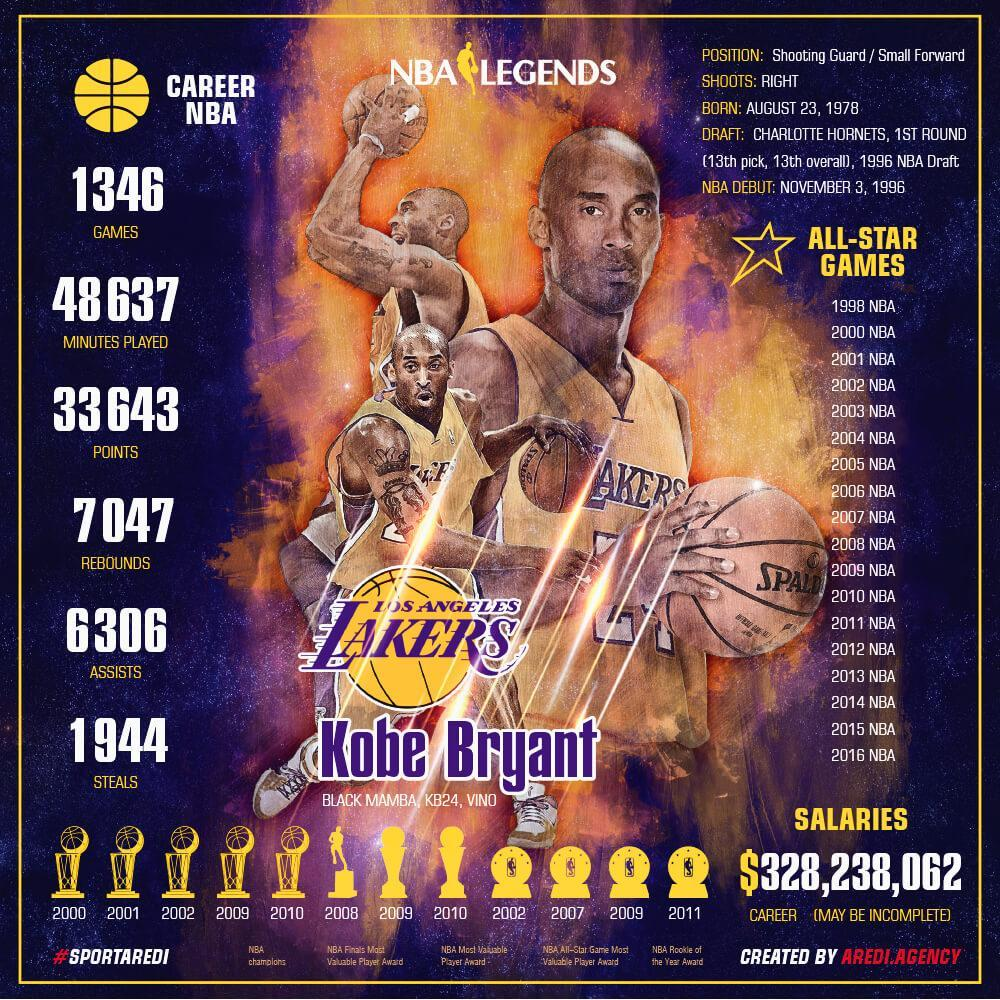How many assists did Kobe Bryant have?
Answer the question with a short phrase. 6306 In which year did he begin his NBA career? 1996 Which were his first 3 all-star games? 1998 NBA, 2000 NBA, 2001 NBA How many games has Kobe Bryant played in his NBA career? 1346 What was the total number of minutes played by Kobe Bryant? 48637 How old was Kobe Bryant when he began his NBA career? 18 What was Kobe Bryant's total earnings in his career? $328,238,062 What were Kobe Bryant's nicknames? Black Mamba, KB24, VINO How many rebounds did Kobe Bryant make? 7047 How many points did Kobe Bryant score? 33643 How many steals did Kobe Bryant have in his NBA career? 1944 Which were his last three all-star games? 2014 NBA, 2015 NBA, 2016 NBA 